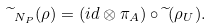Convert formula to latex. <formula><loc_0><loc_0><loc_500><loc_500>\widetilde { \ } _ { N _ { P } } ( \rho ) = ( i d \otimes \pi _ { A } ) \circ \widetilde { \ } ( \rho _ { U } ) .</formula> 